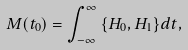Convert formula to latex. <formula><loc_0><loc_0><loc_500><loc_500>M ( t _ { 0 } ) = \int _ { - \infty } ^ { \infty } { \{ H _ { 0 } , H _ { 1 } \} d t } ,</formula> 